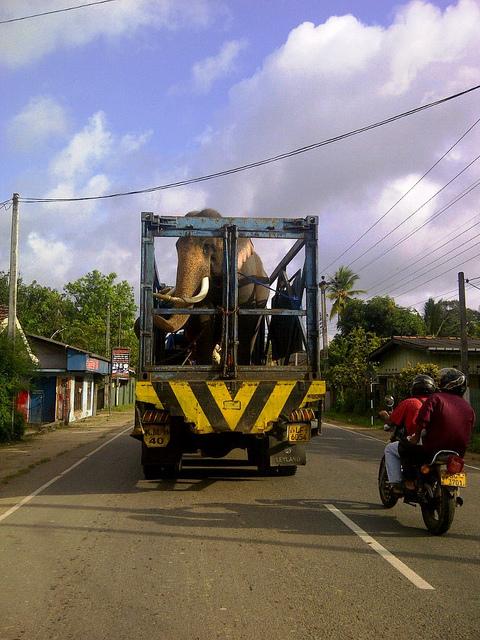What is on the truck?
Concise answer only. Elephant. Where is the elephant?
Concise answer only. Truck. What kind of vehicle is this?
Quick response, please. Truck. 